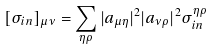Convert formula to latex. <formula><loc_0><loc_0><loc_500><loc_500>[ \sigma _ { i n } ] _ { \mu \nu } = \sum _ { \eta \rho } | a _ { \mu \eta } | ^ { 2 } | a _ { \nu \rho } | ^ { 2 } \sigma _ { i n } ^ { \eta \rho }</formula> 